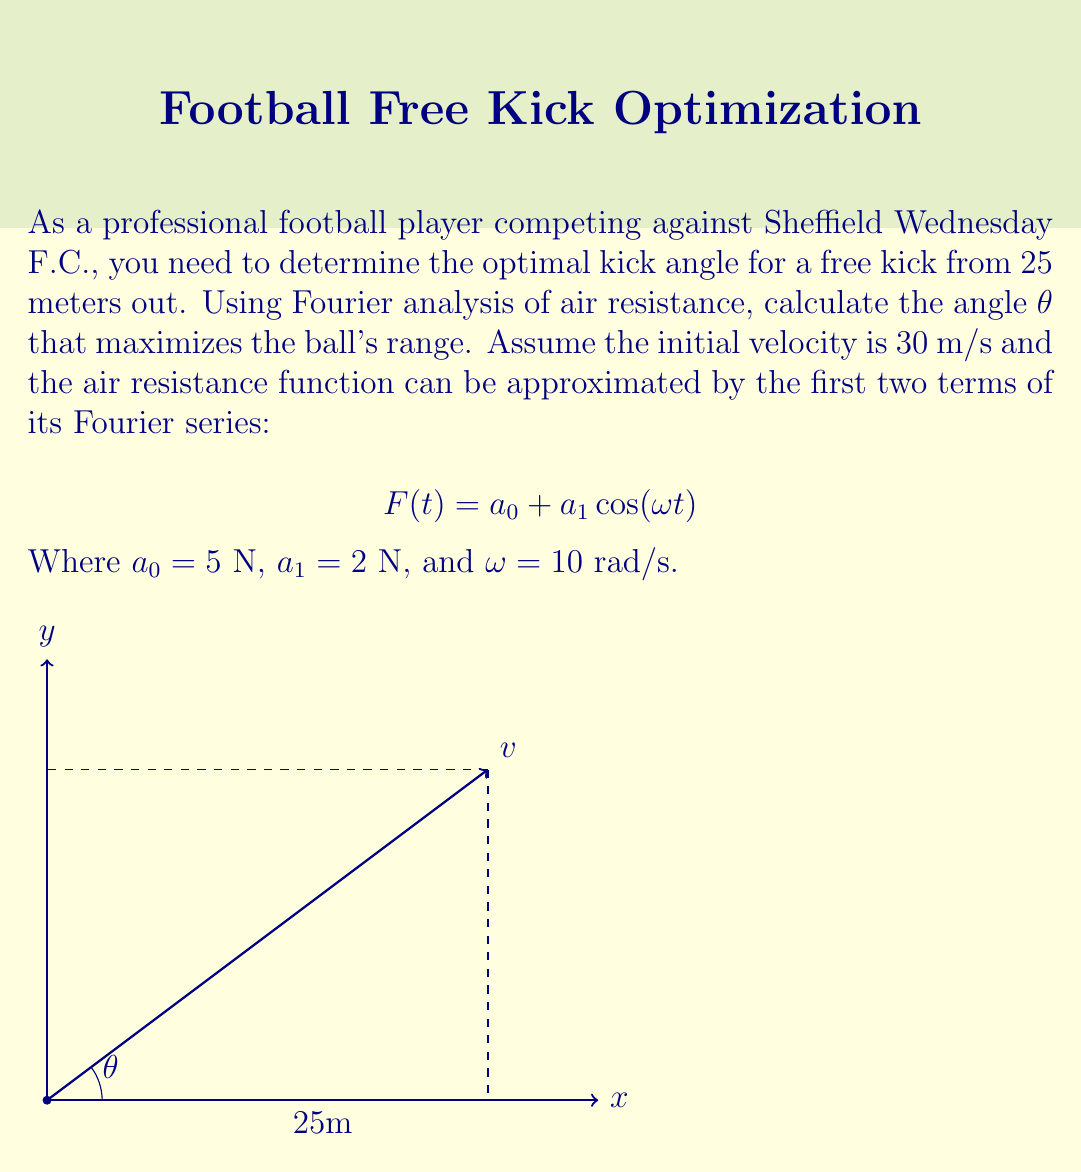Give your solution to this math problem. To find the optimal kick angle using Fourier analysis of air resistance, we'll follow these steps:

1) The range of the projectile is given by:

   $$ R = \frac{v_0^2}{g} \sin(2\theta) \left(1 - \frac{F_{avg}}{mg}\right) $$

   Where $v_0$ is the initial velocity, $g$ is the acceleration due to gravity, $\theta$ is the launch angle, and $F_{avg}$ is the average air resistance force.

2) We need to find $F_{avg}$ using the given Fourier series approximation:

   $$ F(t) = a_0 + a_1 \cos(\omega t) $$

3) The average force over one period is:

   $$ F_{avg} = \frac{1}{T} \int_0^T F(t) dt = \frac{1}{T} \int_0^T (a_0 + a_1 \cos(\omega t)) dt $$

4) Solving this integral:

   $$ F_{avg} = a_0 + \frac{a_1}{\omega T} [\sin(\omega T) - \sin(0)] = a_0 = 5 \text{ N} $$

5) Now, we can substitute this into our range equation:

   $$ R = \frac{(30 \text{ m/s})^2}{9.8 \text{ m/s}^2} \sin(2\theta) \left(1 - \frac{5 \text{ N}}{m \cdot 9.8 \text{ m/s}^2}\right) $$

6) To maximize R, we need to maximize $\sin(2\theta)$. This occurs when $2\theta = 90°$ or $\theta = 45°$.

7) Therefore, the optimal kick angle that maximizes the range is 45°.
Answer: 45° 